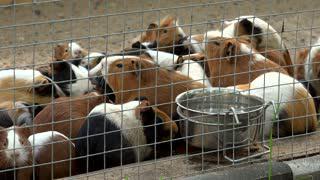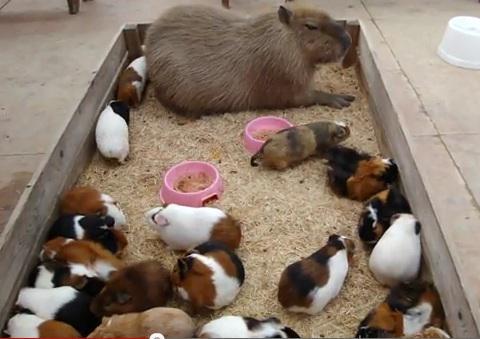The first image is the image on the left, the second image is the image on the right. Examine the images to the left and right. Is the description "Both images show variously colored hamsters arranged in stepped rows." accurate? Answer yes or no. No. The first image is the image on the left, the second image is the image on the right. Considering the images on both sides, is "Both images show a large number of guinea pigs arranged in rows on stair steps." valid? Answer yes or no. No. 